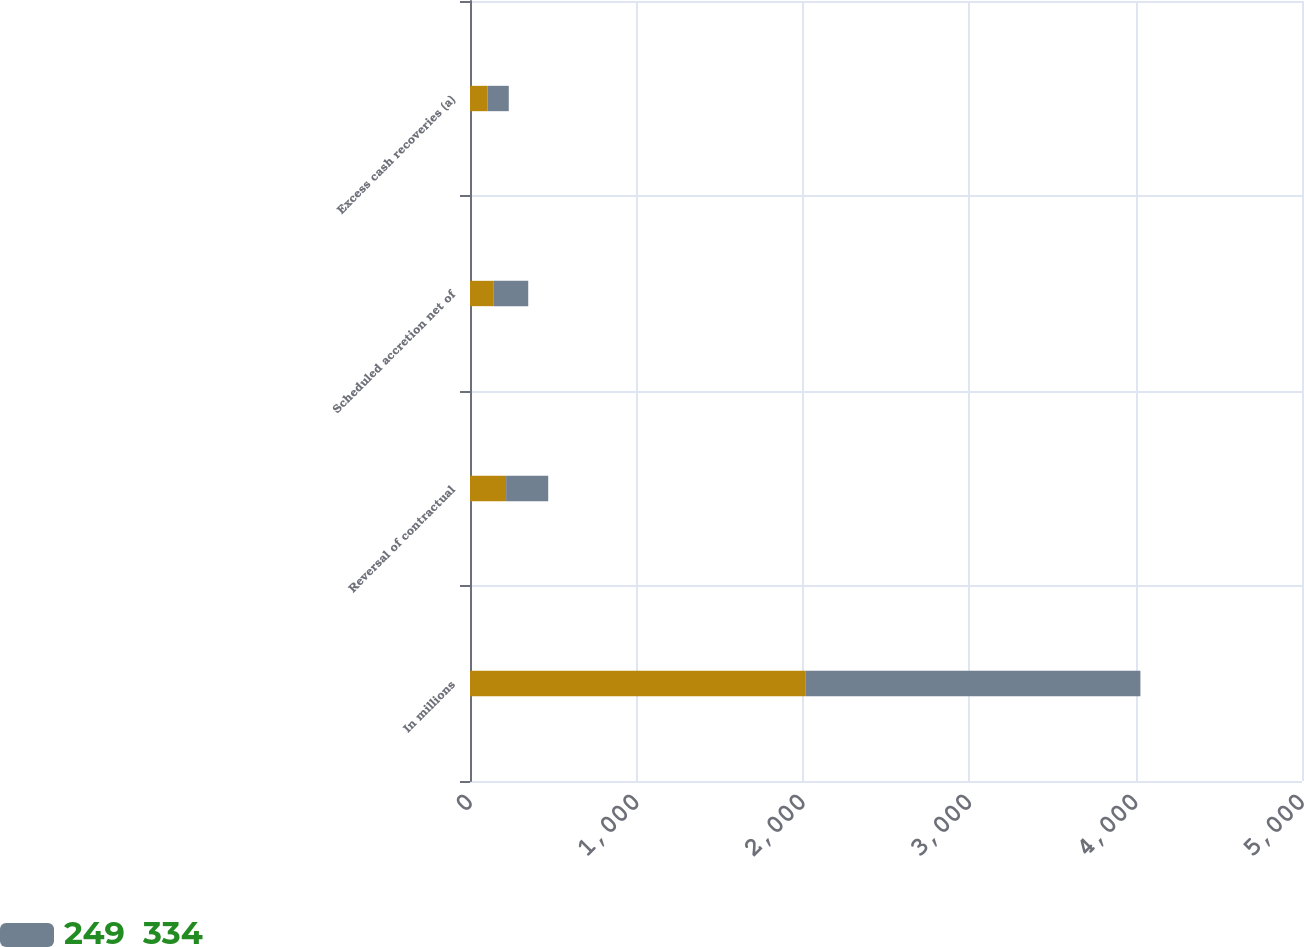Convert chart. <chart><loc_0><loc_0><loc_500><loc_500><stacked_bar_chart><ecel><fcel>In millions<fcel>Reversal of contractual<fcel>Scheduled accretion net of<fcel>Excess cash recoveries (a)<nl><fcel>nan<fcel>2015<fcel>217<fcel>143<fcel>106<nl><fcel>249  334<fcel>2014<fcel>253<fcel>207<fcel>127<nl></chart> 